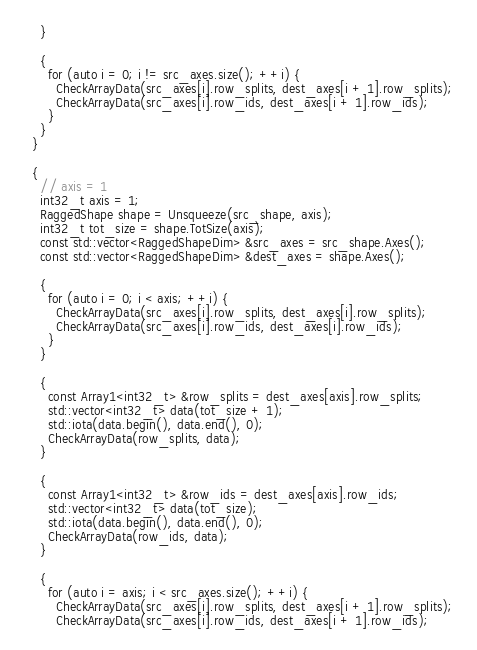<code> <loc_0><loc_0><loc_500><loc_500><_Cuda_>    }

    {
      for (auto i = 0; i != src_axes.size(); ++i) {
        CheckArrayData(src_axes[i].row_splits, dest_axes[i + 1].row_splits);
        CheckArrayData(src_axes[i].row_ids, dest_axes[i + 1].row_ids);
      }
    }
  }

  {
    // axis = 1
    int32_t axis = 1;
    RaggedShape shape = Unsqueeze(src_shape, axis);
    int32_t tot_size = shape.TotSize(axis);
    const std::vector<RaggedShapeDim> &src_axes = src_shape.Axes();
    const std::vector<RaggedShapeDim> &dest_axes = shape.Axes();

    {
      for (auto i = 0; i < axis; ++i) {
        CheckArrayData(src_axes[i].row_splits, dest_axes[i].row_splits);
        CheckArrayData(src_axes[i].row_ids, dest_axes[i].row_ids);
      }
    }

    {
      const Array1<int32_t> &row_splits = dest_axes[axis].row_splits;
      std::vector<int32_t> data(tot_size + 1);
      std::iota(data.begin(), data.end(), 0);
      CheckArrayData(row_splits, data);
    }

    {
      const Array1<int32_t> &row_ids = dest_axes[axis].row_ids;
      std::vector<int32_t> data(tot_size);
      std::iota(data.begin(), data.end(), 0);
      CheckArrayData(row_ids, data);
    }

    {
      for (auto i = axis; i < src_axes.size(); ++i) {
        CheckArrayData(src_axes[i].row_splits, dest_axes[i + 1].row_splits);
        CheckArrayData(src_axes[i].row_ids, dest_axes[i + 1].row_ids);</code> 